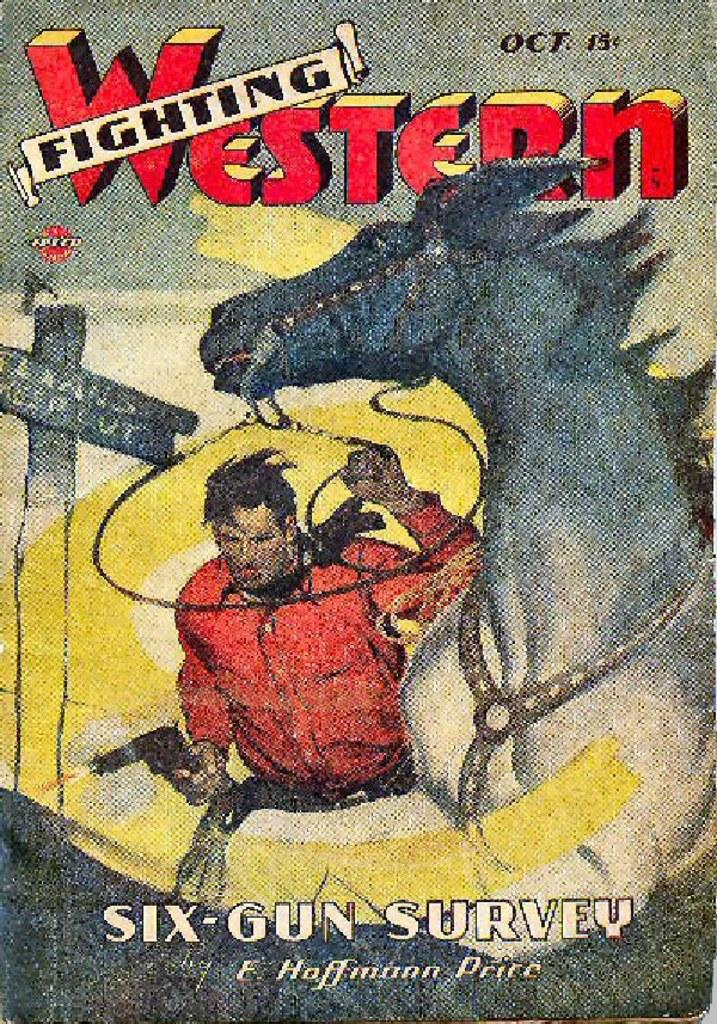<image>
Offer a succinct explanation of the picture presented. The cover of Six-Gun Survey has a drawing of a cowboy and a horse. 